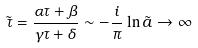<formula> <loc_0><loc_0><loc_500><loc_500>\tilde { \tau } = \frac { \alpha \tau + \beta } { \gamma \tau + \delta } \sim - \frac { i } { \pi } \ln \tilde { a } \rightarrow \infty</formula> 